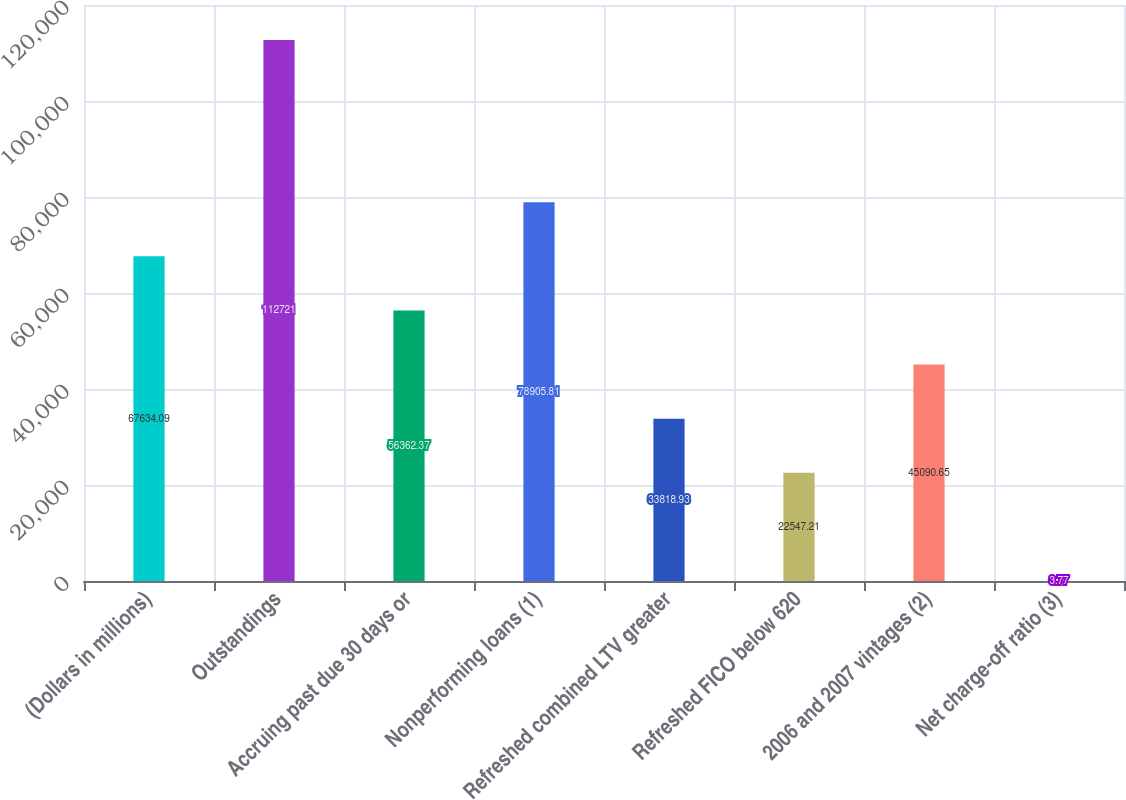<chart> <loc_0><loc_0><loc_500><loc_500><bar_chart><fcel>(Dollars in millions)<fcel>Outstandings<fcel>Accruing past due 30 days or<fcel>Nonperforming loans (1)<fcel>Refreshed combined LTV greater<fcel>Refreshed FICO below 620<fcel>2006 and 2007 vintages (2)<fcel>Net charge-off ratio (3)<nl><fcel>67634.1<fcel>112721<fcel>56362.4<fcel>78905.8<fcel>33818.9<fcel>22547.2<fcel>45090.7<fcel>3.77<nl></chart> 